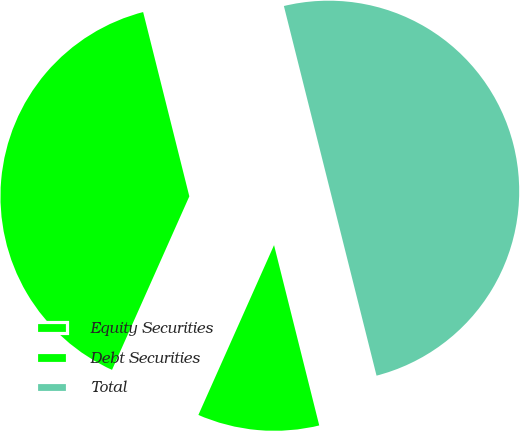<chart> <loc_0><loc_0><loc_500><loc_500><pie_chart><fcel>Equity Securities<fcel>Debt Securities<fcel>Total<nl><fcel>39.42%<fcel>10.58%<fcel>50.0%<nl></chart> 